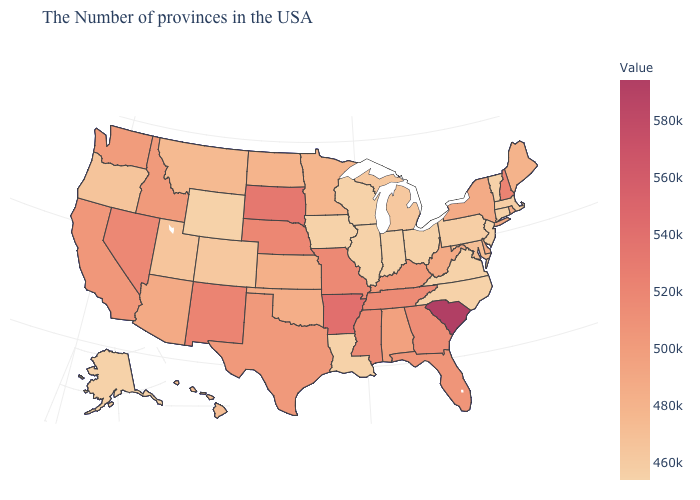Does the map have missing data?
Short answer required. No. Among the states that border Florida , which have the highest value?
Keep it brief. Georgia. Does Montana have the lowest value in the West?
Quick response, please. No. Which states have the lowest value in the West?
Short answer required. Wyoming, Alaska. Among the states that border Maryland , which have the highest value?
Give a very brief answer. West Virginia. Which states have the lowest value in the Northeast?
Write a very short answer. Vermont, Connecticut, New Jersey. 